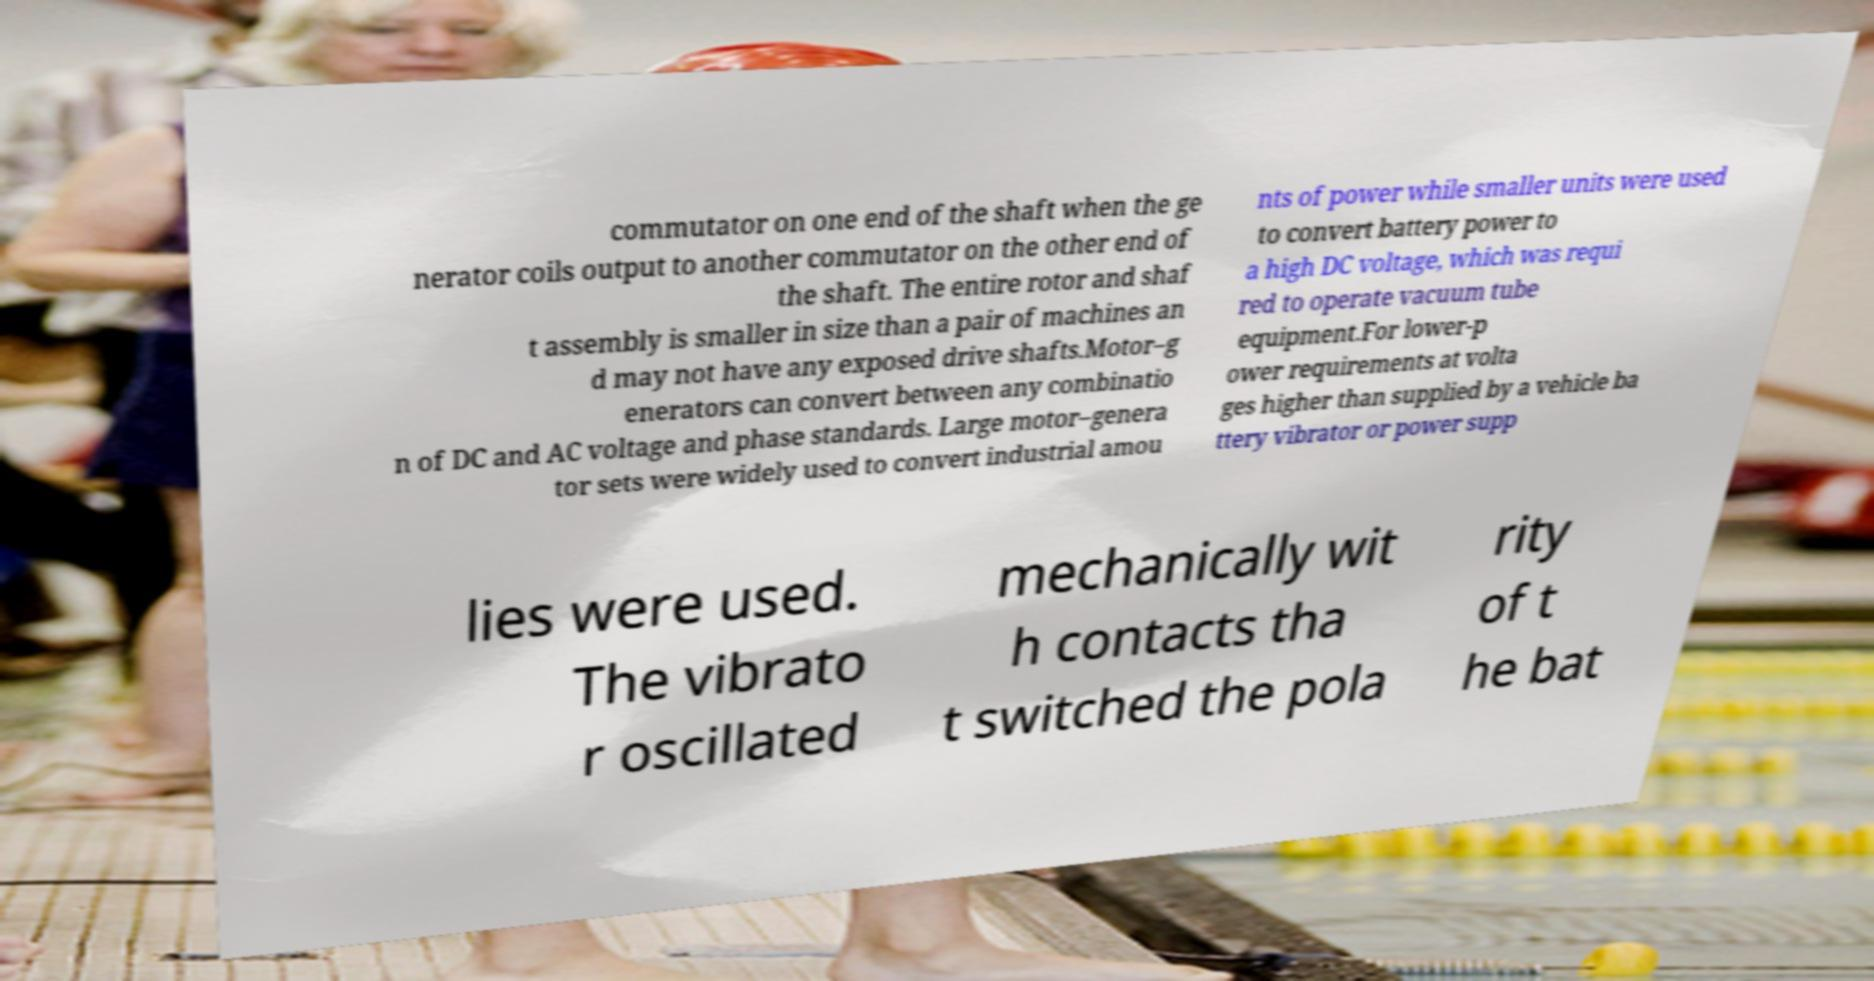Could you extract and type out the text from this image? commutator on one end of the shaft when the ge nerator coils output to another commutator on the other end of the shaft. The entire rotor and shaf t assembly is smaller in size than a pair of machines an d may not have any exposed drive shafts.Motor–g enerators can convert between any combinatio n of DC and AC voltage and phase standards. Large motor–genera tor sets were widely used to convert industrial amou nts of power while smaller units were used to convert battery power to a high DC voltage, which was requi red to operate vacuum tube equipment.For lower-p ower requirements at volta ges higher than supplied by a vehicle ba ttery vibrator or power supp lies were used. The vibrato r oscillated mechanically wit h contacts tha t switched the pola rity of t he bat 